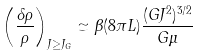<formula> <loc_0><loc_0><loc_500><loc_500>\left ( \frac { \delta \rho } { \rho } \right ) _ { J \geq J _ { G } } \simeq \beta ( 8 \pi L ) \frac { ( G J ^ { 2 } ) ^ { 3 / 2 } } { G \mu }</formula> 